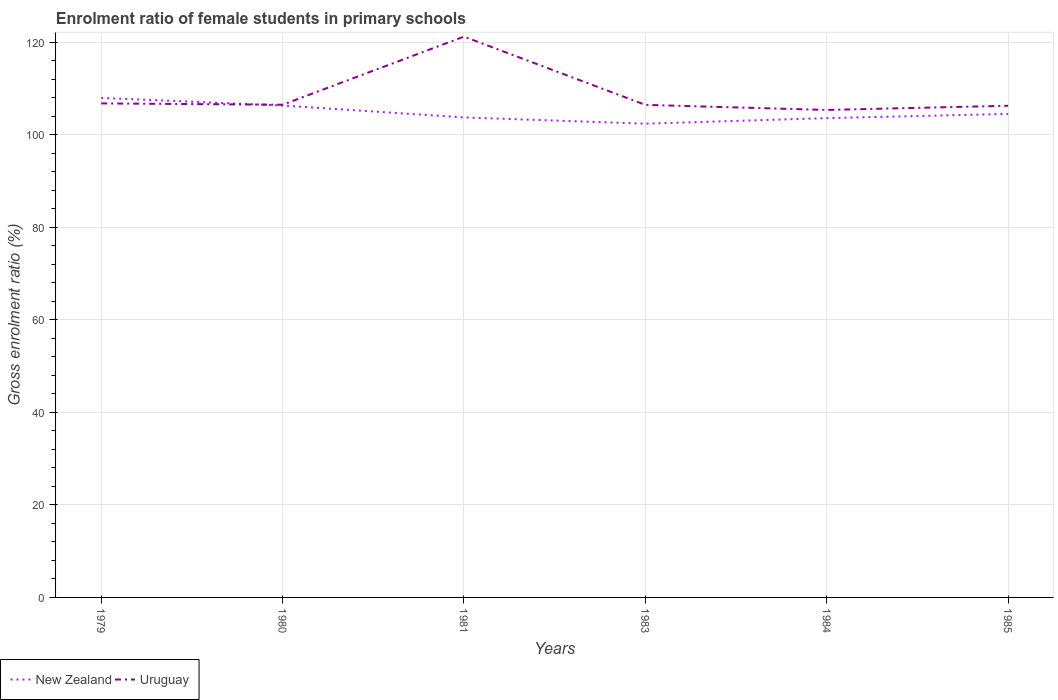How many different coloured lines are there?
Your answer should be compact. 2. Does the line corresponding to New Zealand intersect with the line corresponding to Uruguay?
Keep it short and to the point. Yes. Across all years, what is the maximum enrolment ratio of female students in primary schools in New Zealand?
Provide a succinct answer. 102.41. What is the total enrolment ratio of female students in primary schools in New Zealand in the graph?
Ensure brevity in your answer.  5.58. What is the difference between the highest and the second highest enrolment ratio of female students in primary schools in Uruguay?
Offer a terse response. 15.86. Is the enrolment ratio of female students in primary schools in New Zealand strictly greater than the enrolment ratio of female students in primary schools in Uruguay over the years?
Offer a terse response. No. Are the values on the major ticks of Y-axis written in scientific E-notation?
Ensure brevity in your answer.  No. Does the graph contain any zero values?
Your answer should be compact. No. Does the graph contain grids?
Your response must be concise. Yes. What is the title of the graph?
Your answer should be compact. Enrolment ratio of female students in primary schools. What is the label or title of the X-axis?
Provide a short and direct response. Years. What is the Gross enrolment ratio (%) in New Zealand in 1979?
Offer a terse response. 107.99. What is the Gross enrolment ratio (%) of Uruguay in 1979?
Your response must be concise. 106.79. What is the Gross enrolment ratio (%) of New Zealand in 1980?
Offer a terse response. 106.33. What is the Gross enrolment ratio (%) in Uruguay in 1980?
Your answer should be compact. 106.5. What is the Gross enrolment ratio (%) in New Zealand in 1981?
Provide a succinct answer. 103.76. What is the Gross enrolment ratio (%) of Uruguay in 1981?
Ensure brevity in your answer.  121.23. What is the Gross enrolment ratio (%) of New Zealand in 1983?
Your answer should be very brief. 102.41. What is the Gross enrolment ratio (%) in Uruguay in 1983?
Offer a very short reply. 106.47. What is the Gross enrolment ratio (%) in New Zealand in 1984?
Offer a very short reply. 103.61. What is the Gross enrolment ratio (%) of Uruguay in 1984?
Provide a succinct answer. 105.38. What is the Gross enrolment ratio (%) in New Zealand in 1985?
Your response must be concise. 104.52. What is the Gross enrolment ratio (%) of Uruguay in 1985?
Ensure brevity in your answer.  106.28. Across all years, what is the maximum Gross enrolment ratio (%) in New Zealand?
Offer a very short reply. 107.99. Across all years, what is the maximum Gross enrolment ratio (%) of Uruguay?
Your answer should be compact. 121.23. Across all years, what is the minimum Gross enrolment ratio (%) in New Zealand?
Your answer should be very brief. 102.41. Across all years, what is the minimum Gross enrolment ratio (%) in Uruguay?
Offer a very short reply. 105.38. What is the total Gross enrolment ratio (%) of New Zealand in the graph?
Make the answer very short. 628.62. What is the total Gross enrolment ratio (%) of Uruguay in the graph?
Offer a terse response. 652.66. What is the difference between the Gross enrolment ratio (%) of New Zealand in 1979 and that in 1980?
Make the answer very short. 1.65. What is the difference between the Gross enrolment ratio (%) of Uruguay in 1979 and that in 1980?
Make the answer very short. 0.29. What is the difference between the Gross enrolment ratio (%) of New Zealand in 1979 and that in 1981?
Offer a very short reply. 4.22. What is the difference between the Gross enrolment ratio (%) of Uruguay in 1979 and that in 1981?
Provide a short and direct response. -14.44. What is the difference between the Gross enrolment ratio (%) in New Zealand in 1979 and that in 1983?
Provide a succinct answer. 5.58. What is the difference between the Gross enrolment ratio (%) of Uruguay in 1979 and that in 1983?
Ensure brevity in your answer.  0.32. What is the difference between the Gross enrolment ratio (%) of New Zealand in 1979 and that in 1984?
Keep it short and to the point. 4.38. What is the difference between the Gross enrolment ratio (%) in Uruguay in 1979 and that in 1984?
Offer a terse response. 1.42. What is the difference between the Gross enrolment ratio (%) in New Zealand in 1979 and that in 1985?
Your answer should be very brief. 3.47. What is the difference between the Gross enrolment ratio (%) in Uruguay in 1979 and that in 1985?
Keep it short and to the point. 0.51. What is the difference between the Gross enrolment ratio (%) of New Zealand in 1980 and that in 1981?
Give a very brief answer. 2.57. What is the difference between the Gross enrolment ratio (%) in Uruguay in 1980 and that in 1981?
Give a very brief answer. -14.73. What is the difference between the Gross enrolment ratio (%) of New Zealand in 1980 and that in 1983?
Your response must be concise. 3.92. What is the difference between the Gross enrolment ratio (%) in Uruguay in 1980 and that in 1983?
Offer a very short reply. 0.03. What is the difference between the Gross enrolment ratio (%) in New Zealand in 1980 and that in 1984?
Give a very brief answer. 2.72. What is the difference between the Gross enrolment ratio (%) in Uruguay in 1980 and that in 1984?
Your answer should be compact. 1.13. What is the difference between the Gross enrolment ratio (%) of New Zealand in 1980 and that in 1985?
Your answer should be compact. 1.82. What is the difference between the Gross enrolment ratio (%) in Uruguay in 1980 and that in 1985?
Keep it short and to the point. 0.22. What is the difference between the Gross enrolment ratio (%) of New Zealand in 1981 and that in 1983?
Provide a succinct answer. 1.35. What is the difference between the Gross enrolment ratio (%) in Uruguay in 1981 and that in 1983?
Offer a very short reply. 14.76. What is the difference between the Gross enrolment ratio (%) of New Zealand in 1981 and that in 1984?
Provide a succinct answer. 0.15. What is the difference between the Gross enrolment ratio (%) in Uruguay in 1981 and that in 1984?
Keep it short and to the point. 15.86. What is the difference between the Gross enrolment ratio (%) in New Zealand in 1981 and that in 1985?
Ensure brevity in your answer.  -0.76. What is the difference between the Gross enrolment ratio (%) of Uruguay in 1981 and that in 1985?
Your answer should be compact. 14.95. What is the difference between the Gross enrolment ratio (%) of New Zealand in 1983 and that in 1984?
Your response must be concise. -1.2. What is the difference between the Gross enrolment ratio (%) of Uruguay in 1983 and that in 1984?
Give a very brief answer. 1.1. What is the difference between the Gross enrolment ratio (%) of New Zealand in 1983 and that in 1985?
Provide a short and direct response. -2.11. What is the difference between the Gross enrolment ratio (%) in Uruguay in 1983 and that in 1985?
Your answer should be compact. 0.19. What is the difference between the Gross enrolment ratio (%) of New Zealand in 1984 and that in 1985?
Ensure brevity in your answer.  -0.91. What is the difference between the Gross enrolment ratio (%) in Uruguay in 1984 and that in 1985?
Offer a terse response. -0.91. What is the difference between the Gross enrolment ratio (%) in New Zealand in 1979 and the Gross enrolment ratio (%) in Uruguay in 1980?
Provide a succinct answer. 1.48. What is the difference between the Gross enrolment ratio (%) of New Zealand in 1979 and the Gross enrolment ratio (%) of Uruguay in 1981?
Give a very brief answer. -13.24. What is the difference between the Gross enrolment ratio (%) of New Zealand in 1979 and the Gross enrolment ratio (%) of Uruguay in 1983?
Offer a terse response. 1.51. What is the difference between the Gross enrolment ratio (%) of New Zealand in 1979 and the Gross enrolment ratio (%) of Uruguay in 1984?
Your answer should be compact. 2.61. What is the difference between the Gross enrolment ratio (%) in New Zealand in 1979 and the Gross enrolment ratio (%) in Uruguay in 1985?
Provide a short and direct response. 1.71. What is the difference between the Gross enrolment ratio (%) of New Zealand in 1980 and the Gross enrolment ratio (%) of Uruguay in 1981?
Keep it short and to the point. -14.9. What is the difference between the Gross enrolment ratio (%) in New Zealand in 1980 and the Gross enrolment ratio (%) in Uruguay in 1983?
Offer a very short reply. -0.14. What is the difference between the Gross enrolment ratio (%) in New Zealand in 1980 and the Gross enrolment ratio (%) in Uruguay in 1984?
Your answer should be compact. 0.96. What is the difference between the Gross enrolment ratio (%) of New Zealand in 1980 and the Gross enrolment ratio (%) of Uruguay in 1985?
Your answer should be very brief. 0.05. What is the difference between the Gross enrolment ratio (%) in New Zealand in 1981 and the Gross enrolment ratio (%) in Uruguay in 1983?
Ensure brevity in your answer.  -2.71. What is the difference between the Gross enrolment ratio (%) of New Zealand in 1981 and the Gross enrolment ratio (%) of Uruguay in 1984?
Provide a succinct answer. -1.61. What is the difference between the Gross enrolment ratio (%) of New Zealand in 1981 and the Gross enrolment ratio (%) of Uruguay in 1985?
Provide a succinct answer. -2.52. What is the difference between the Gross enrolment ratio (%) in New Zealand in 1983 and the Gross enrolment ratio (%) in Uruguay in 1984?
Give a very brief answer. -2.97. What is the difference between the Gross enrolment ratio (%) of New Zealand in 1983 and the Gross enrolment ratio (%) of Uruguay in 1985?
Make the answer very short. -3.87. What is the difference between the Gross enrolment ratio (%) of New Zealand in 1984 and the Gross enrolment ratio (%) of Uruguay in 1985?
Your answer should be compact. -2.67. What is the average Gross enrolment ratio (%) of New Zealand per year?
Offer a terse response. 104.77. What is the average Gross enrolment ratio (%) of Uruguay per year?
Your answer should be compact. 108.78. In the year 1979, what is the difference between the Gross enrolment ratio (%) of New Zealand and Gross enrolment ratio (%) of Uruguay?
Your answer should be very brief. 1.19. In the year 1980, what is the difference between the Gross enrolment ratio (%) in New Zealand and Gross enrolment ratio (%) in Uruguay?
Ensure brevity in your answer.  -0.17. In the year 1981, what is the difference between the Gross enrolment ratio (%) of New Zealand and Gross enrolment ratio (%) of Uruguay?
Offer a terse response. -17.47. In the year 1983, what is the difference between the Gross enrolment ratio (%) of New Zealand and Gross enrolment ratio (%) of Uruguay?
Make the answer very short. -4.06. In the year 1984, what is the difference between the Gross enrolment ratio (%) of New Zealand and Gross enrolment ratio (%) of Uruguay?
Your response must be concise. -1.77. In the year 1985, what is the difference between the Gross enrolment ratio (%) in New Zealand and Gross enrolment ratio (%) in Uruguay?
Keep it short and to the point. -1.76. What is the ratio of the Gross enrolment ratio (%) in New Zealand in 1979 to that in 1980?
Make the answer very short. 1.02. What is the ratio of the Gross enrolment ratio (%) of New Zealand in 1979 to that in 1981?
Offer a terse response. 1.04. What is the ratio of the Gross enrolment ratio (%) in Uruguay in 1979 to that in 1981?
Offer a very short reply. 0.88. What is the ratio of the Gross enrolment ratio (%) in New Zealand in 1979 to that in 1983?
Provide a succinct answer. 1.05. What is the ratio of the Gross enrolment ratio (%) of New Zealand in 1979 to that in 1984?
Your response must be concise. 1.04. What is the ratio of the Gross enrolment ratio (%) in Uruguay in 1979 to that in 1984?
Ensure brevity in your answer.  1.01. What is the ratio of the Gross enrolment ratio (%) of New Zealand in 1979 to that in 1985?
Make the answer very short. 1.03. What is the ratio of the Gross enrolment ratio (%) in New Zealand in 1980 to that in 1981?
Give a very brief answer. 1.02. What is the ratio of the Gross enrolment ratio (%) in Uruguay in 1980 to that in 1981?
Give a very brief answer. 0.88. What is the ratio of the Gross enrolment ratio (%) in New Zealand in 1980 to that in 1983?
Your response must be concise. 1.04. What is the ratio of the Gross enrolment ratio (%) in Uruguay in 1980 to that in 1983?
Your answer should be compact. 1. What is the ratio of the Gross enrolment ratio (%) of New Zealand in 1980 to that in 1984?
Provide a short and direct response. 1.03. What is the ratio of the Gross enrolment ratio (%) in Uruguay in 1980 to that in 1984?
Ensure brevity in your answer.  1.01. What is the ratio of the Gross enrolment ratio (%) in New Zealand in 1980 to that in 1985?
Ensure brevity in your answer.  1.02. What is the ratio of the Gross enrolment ratio (%) in Uruguay in 1980 to that in 1985?
Make the answer very short. 1. What is the ratio of the Gross enrolment ratio (%) of New Zealand in 1981 to that in 1983?
Provide a short and direct response. 1.01. What is the ratio of the Gross enrolment ratio (%) of Uruguay in 1981 to that in 1983?
Make the answer very short. 1.14. What is the ratio of the Gross enrolment ratio (%) in Uruguay in 1981 to that in 1984?
Keep it short and to the point. 1.15. What is the ratio of the Gross enrolment ratio (%) in New Zealand in 1981 to that in 1985?
Your answer should be very brief. 0.99. What is the ratio of the Gross enrolment ratio (%) of Uruguay in 1981 to that in 1985?
Your response must be concise. 1.14. What is the ratio of the Gross enrolment ratio (%) of New Zealand in 1983 to that in 1984?
Offer a very short reply. 0.99. What is the ratio of the Gross enrolment ratio (%) of Uruguay in 1983 to that in 1984?
Keep it short and to the point. 1.01. What is the ratio of the Gross enrolment ratio (%) in New Zealand in 1983 to that in 1985?
Offer a terse response. 0.98. What is the ratio of the Gross enrolment ratio (%) of Uruguay in 1983 to that in 1985?
Provide a short and direct response. 1. What is the ratio of the Gross enrolment ratio (%) in New Zealand in 1984 to that in 1985?
Provide a succinct answer. 0.99. What is the difference between the highest and the second highest Gross enrolment ratio (%) of New Zealand?
Keep it short and to the point. 1.65. What is the difference between the highest and the second highest Gross enrolment ratio (%) in Uruguay?
Keep it short and to the point. 14.44. What is the difference between the highest and the lowest Gross enrolment ratio (%) of New Zealand?
Ensure brevity in your answer.  5.58. What is the difference between the highest and the lowest Gross enrolment ratio (%) in Uruguay?
Keep it short and to the point. 15.86. 